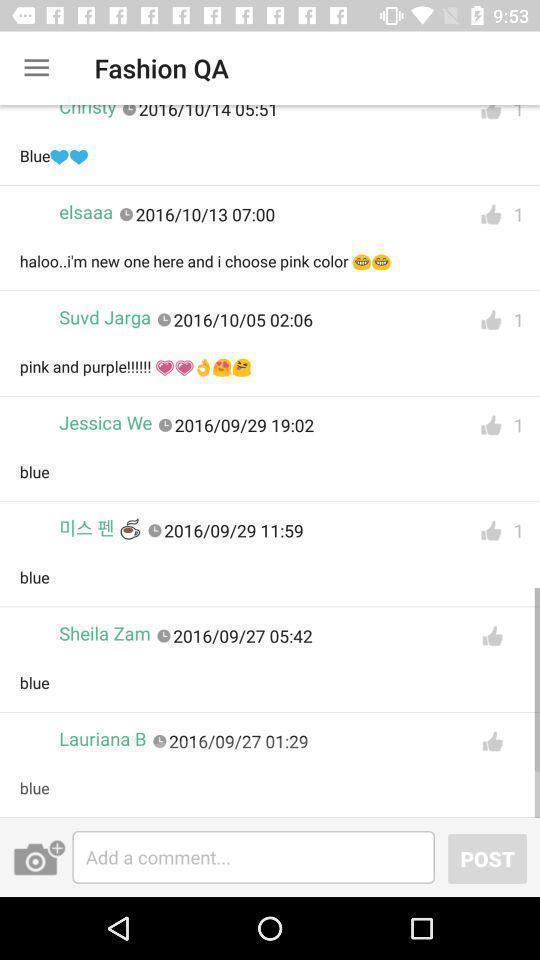Tell me about the visual elements in this screen capture. Page showing list of comments on a post. 